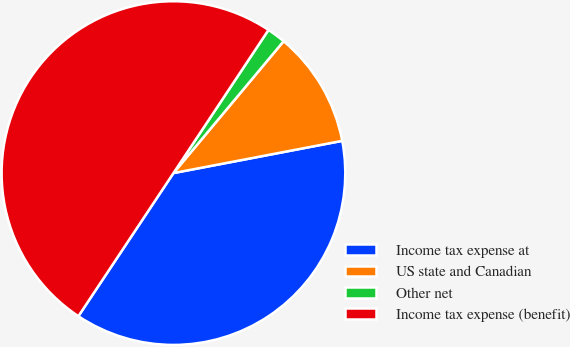Convert chart to OTSL. <chart><loc_0><loc_0><loc_500><loc_500><pie_chart><fcel>Income tax expense at<fcel>US state and Canadian<fcel>Other net<fcel>Income tax expense (benefit)<nl><fcel>37.34%<fcel>10.92%<fcel>1.75%<fcel>50.0%<nl></chart> 